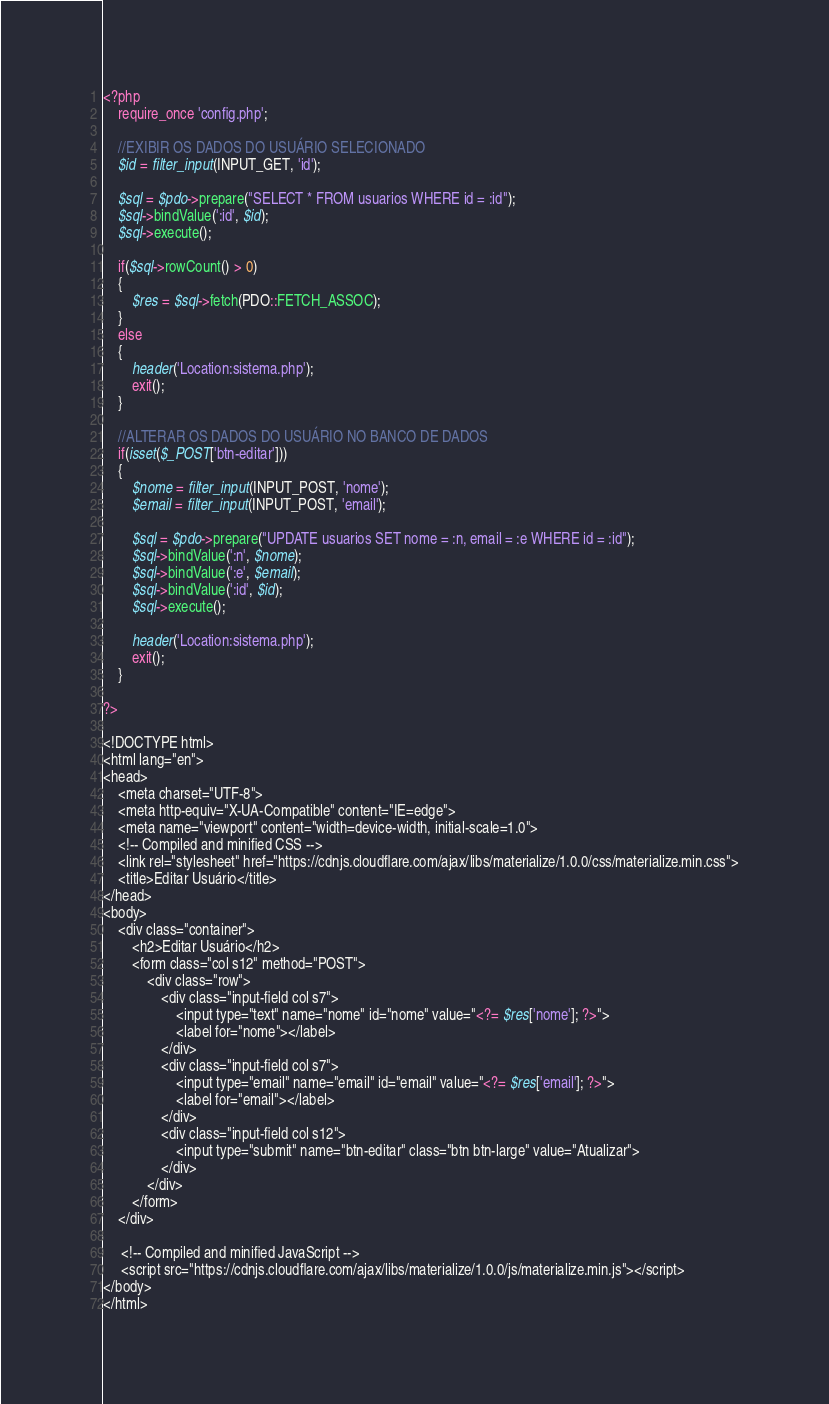<code> <loc_0><loc_0><loc_500><loc_500><_PHP_><?php
    require_once 'config.php';

    //EXIBIR OS DADOS DO USUÁRIO SELECIONADO
    $id = filter_input(INPUT_GET, 'id');
    
    $sql = $pdo->prepare("SELECT * FROM usuarios WHERE id = :id");
    $sql->bindValue(':id', $id);
    $sql->execute();

    if($sql->rowCount() > 0)
    {
        $res = $sql->fetch(PDO::FETCH_ASSOC);
    }
    else
    {
        header('Location:sistema.php');
        exit();
    }

    //ALTERAR OS DADOS DO USUÁRIO NO BANCO DE DADOS
    if(isset($_POST['btn-editar']))
    {
        $nome = filter_input(INPUT_POST, 'nome');
        $email = filter_input(INPUT_POST, 'email');

        $sql = $pdo->prepare("UPDATE usuarios SET nome = :n, email = :e WHERE id = :id");
        $sql->bindValue(':n', $nome);
        $sql->bindValue(':e', $email);
        $sql->bindValue(':id', $id);
        $sql->execute();

        header('Location:sistema.php');
        exit();
    }

?>

<!DOCTYPE html>
<html lang="en">
<head>
    <meta charset="UTF-8">
    <meta http-equiv="X-UA-Compatible" content="IE=edge">
    <meta name="viewport" content="width=device-width, initial-scale=1.0">
    <!-- Compiled and minified CSS -->
    <link rel="stylesheet" href="https://cdnjs.cloudflare.com/ajax/libs/materialize/1.0.0/css/materialize.min.css">
    <title>Editar Usuário</title>
</head>
<body>
    <div class="container">
        <h2>Editar Usuário</h2>
        <form class="col s12" method="POST">
            <div class="row">
                <div class="input-field col s7">
                    <input type="text" name="nome" id="nome" value="<?= $res['nome']; ?>">
                    <label for="nome"></label>
                </div>
                <div class="input-field col s7">
                    <input type="email" name="email" id="email" value="<?= $res['email']; ?>">
                    <label for="email"></label>
                </div>
                <div class="input-field col s12">
                    <input type="submit" name="btn-editar" class="btn btn-large" value="Atualizar">
                </div>
            </div>
        </form>
    </div>

     <!-- Compiled and minified JavaScript -->
     <script src="https://cdnjs.cloudflare.com/ajax/libs/materialize/1.0.0/js/materialize.min.js"></script>
</body>
</html>
</code> 